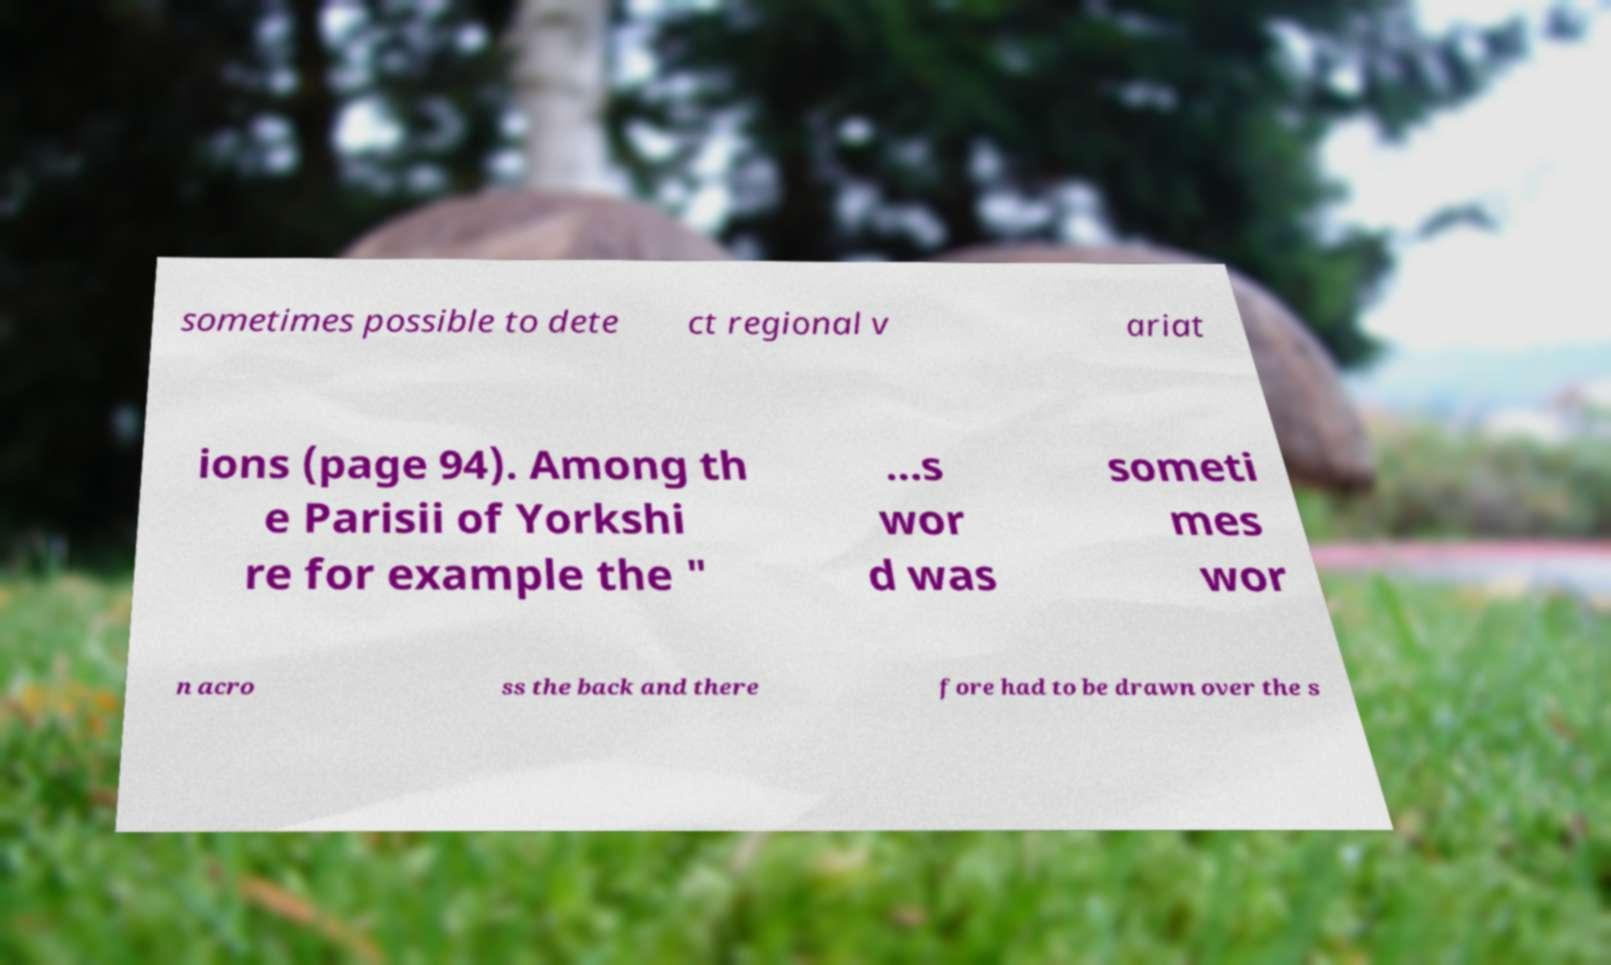Could you assist in decoding the text presented in this image and type it out clearly? sometimes possible to dete ct regional v ariat ions (page 94). Among th e Parisii of Yorkshi re for example the " ...s wor d was someti mes wor n acro ss the back and there fore had to be drawn over the s 